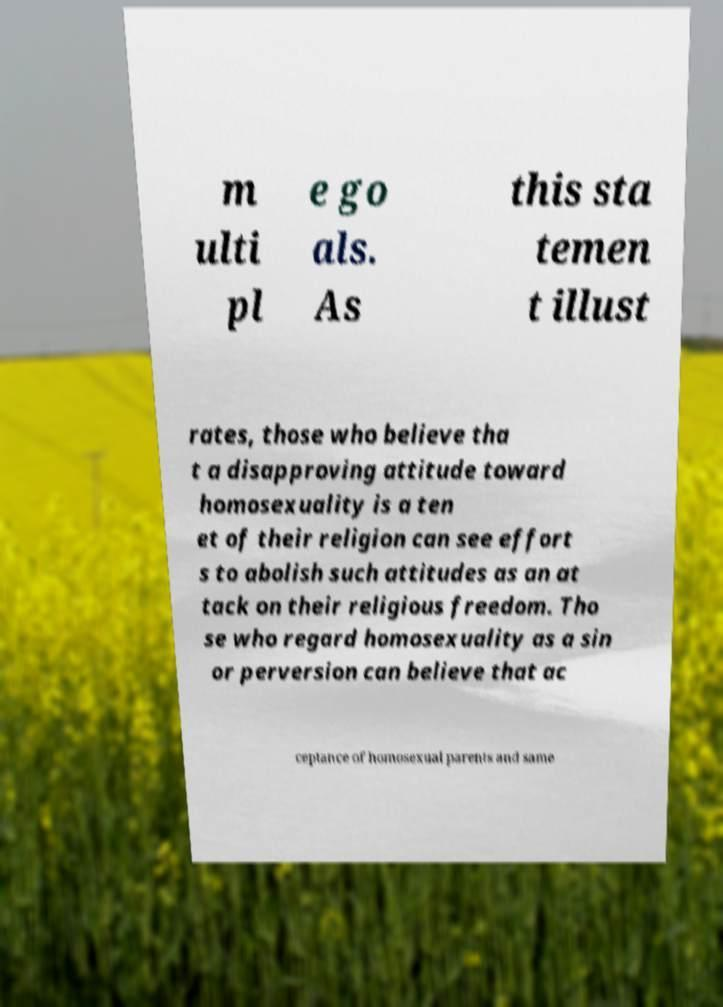Please read and relay the text visible in this image. What does it say? m ulti pl e go als. As this sta temen t illust rates, those who believe tha t a disapproving attitude toward homosexuality is a ten et of their religion can see effort s to abolish such attitudes as an at tack on their religious freedom. Tho se who regard homosexuality as a sin or perversion can believe that ac ceptance of homosexual parents and same 